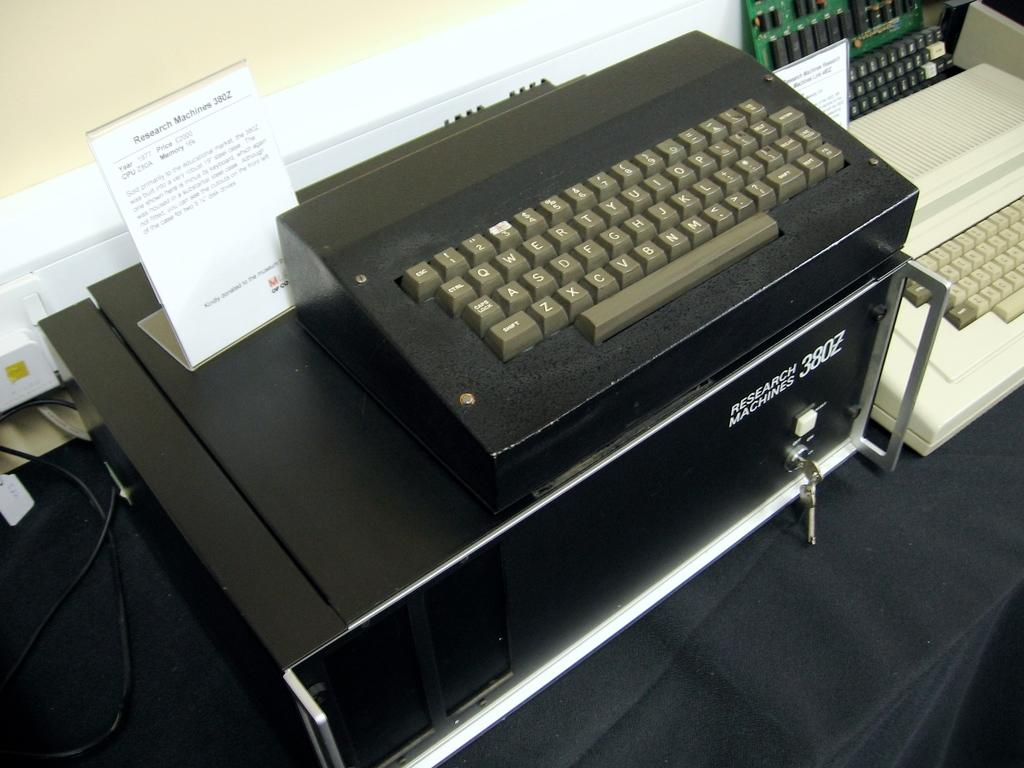What is the main object in the image? There is a black typewriter in the image. Where is the black typewriter located? The black typewriter is placed on a table. What other typewriter can be seen in the image? There is a white color typewriter in the image. How are the two typewriters positioned in relation to each other? The white color typewriter is beside the black typewriter. What type of cream can be seen on the person's face in the image? There is no person present in the image, so there is no cream on anyone's face. What type of marble is used to make the table in the image? The image does not provide information about the material used to make the table, so we cannot determine if marble is used. 